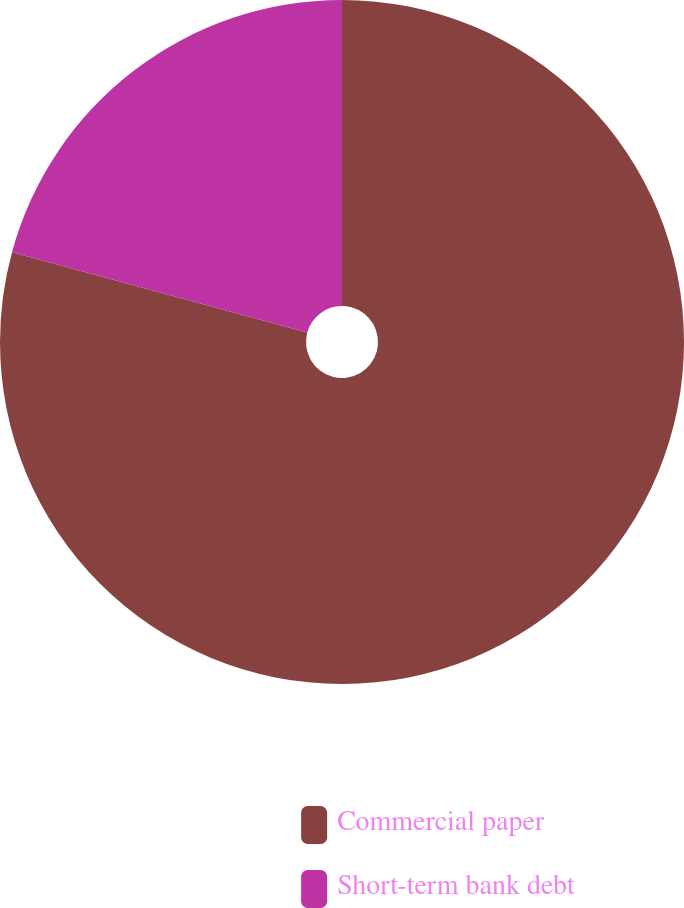Convert chart. <chart><loc_0><loc_0><loc_500><loc_500><pie_chart><fcel>Commercial paper<fcel>Short-term bank debt<nl><fcel>79.23%<fcel>20.77%<nl></chart> 